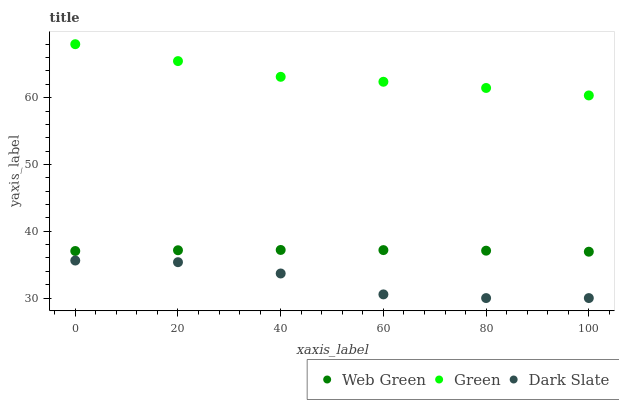Does Dark Slate have the minimum area under the curve?
Answer yes or no. Yes. Does Green have the maximum area under the curve?
Answer yes or no. Yes. Does Web Green have the minimum area under the curve?
Answer yes or no. No. Does Web Green have the maximum area under the curve?
Answer yes or no. No. Is Web Green the smoothest?
Answer yes or no. Yes. Is Dark Slate the roughest?
Answer yes or no. Yes. Is Green the smoothest?
Answer yes or no. No. Is Green the roughest?
Answer yes or no. No. Does Dark Slate have the lowest value?
Answer yes or no. Yes. Does Web Green have the lowest value?
Answer yes or no. No. Does Green have the highest value?
Answer yes or no. Yes. Does Web Green have the highest value?
Answer yes or no. No. Is Dark Slate less than Web Green?
Answer yes or no. Yes. Is Green greater than Web Green?
Answer yes or no. Yes. Does Dark Slate intersect Web Green?
Answer yes or no. No. 